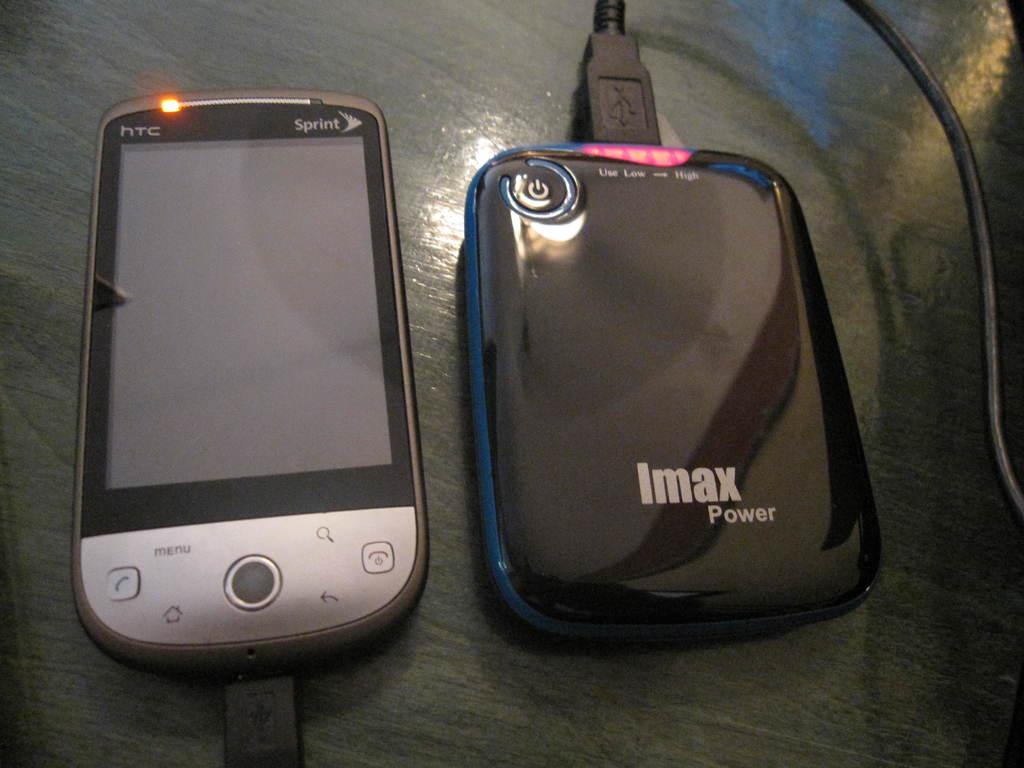What kind of plane is this?
Ensure brevity in your answer.  Unanswerable. What phone company does this phone work with?
Your answer should be compact. Sprint. 